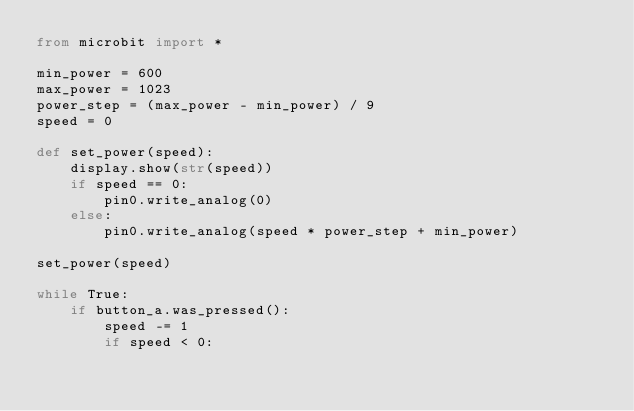Convert code to text. <code><loc_0><loc_0><loc_500><loc_500><_Python_>from microbit import *

min_power = 600
max_power = 1023
power_step = (max_power - min_power) / 9
speed = 0

def set_power(speed):
    display.show(str(speed))
    if speed == 0:
        pin0.write_analog(0)
    else:
        pin0.write_analog(speed * power_step + min_power)
   
set_power(speed)
   
while True:
    if button_a.was_pressed():
        speed -= 1
        if speed < 0:</code> 